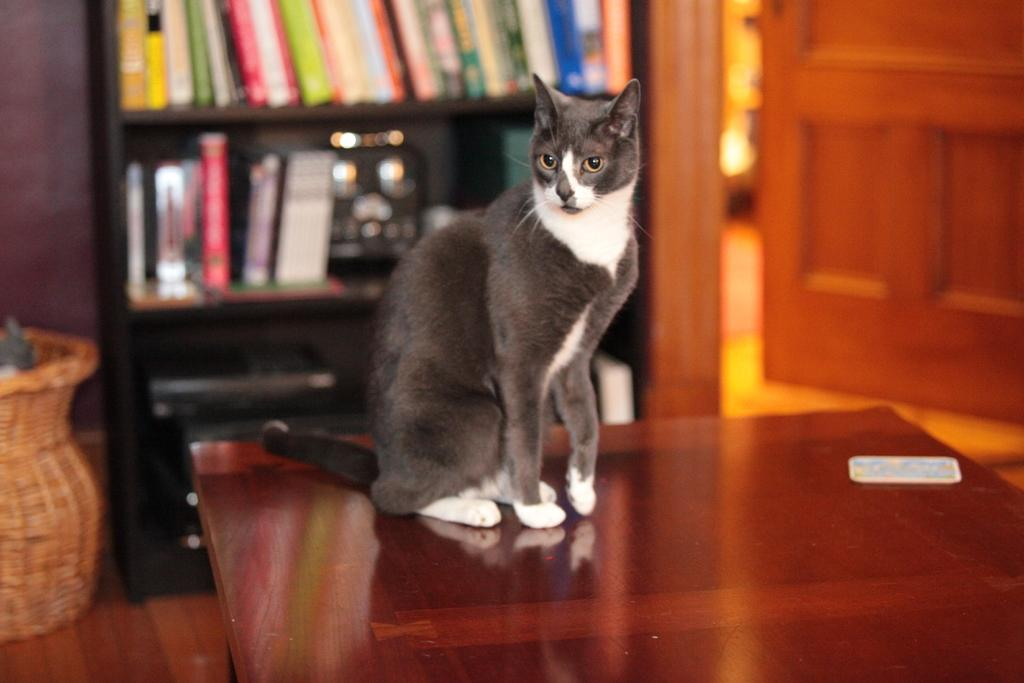What type of animal is in the image? There is a cat in the image. Where is the cat located in relation to the table? The cat is behind a table. What can be seen behind the cat? There is a bookshelf behind the cat. What is visible on the right side of the image? There is a door on the right side of the image. How does the crowd affect the cat's behavior in the image? There is no crowd present in the image, so it cannot affect the cat's behavior. 